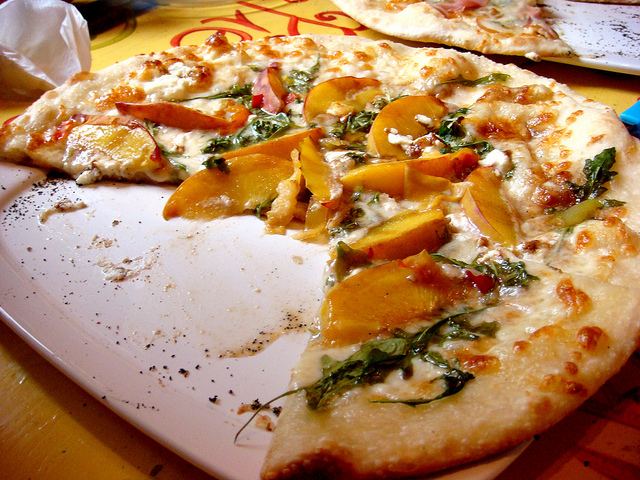How many dining tables are there? Based on the image provided, there appears to be only one visible dining table, as indicated by the presence of a single table edge and tabletop in the photograph. 